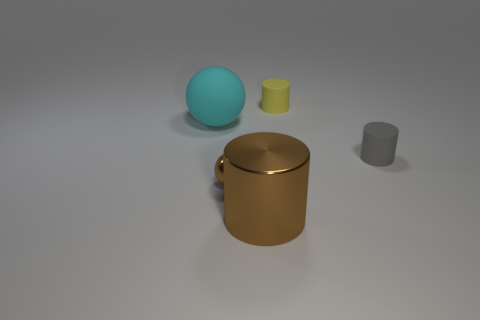Add 4 cyan things. How many objects exist? 9 Subtract all cylinders. How many objects are left? 2 Add 2 gray cylinders. How many gray cylinders exist? 3 Subtract 1 yellow cylinders. How many objects are left? 4 Subtract all large red balls. Subtract all small metal objects. How many objects are left? 4 Add 3 cyan rubber balls. How many cyan rubber balls are left? 4 